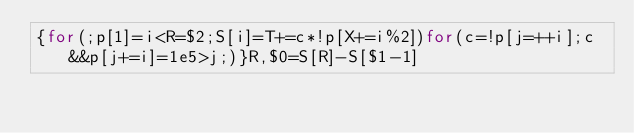<code> <loc_0><loc_0><loc_500><loc_500><_Awk_>{for(;p[1]=i<R=$2;S[i]=T+=c*!p[X+=i%2])for(c=!p[j=++i];c&&p[j+=i]=1e5>j;)}R,$0=S[R]-S[$1-1]</code> 